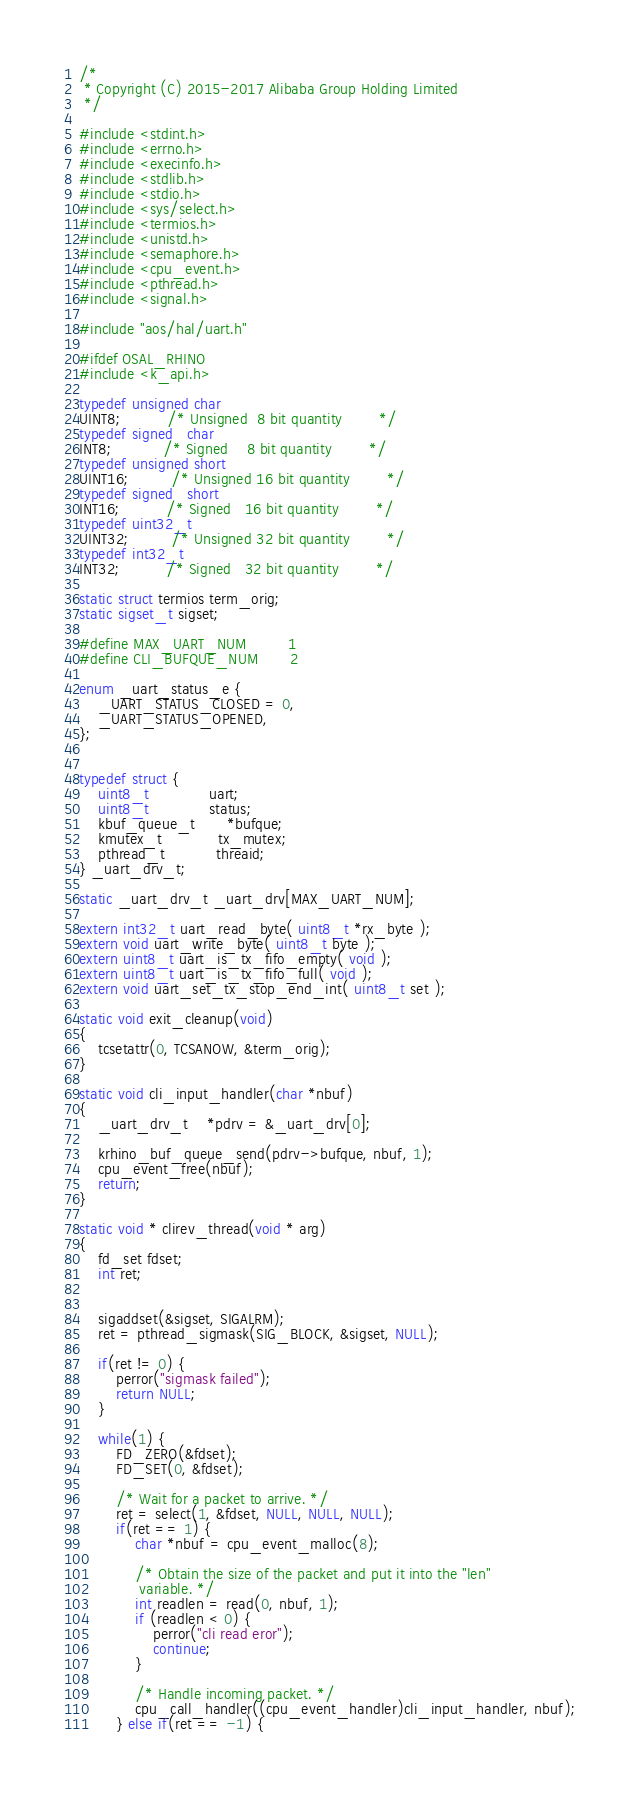<code> <loc_0><loc_0><loc_500><loc_500><_C_>/*
 * Copyright (C) 2015-2017 Alibaba Group Holding Limited
 */

#include <stdint.h>
#include <errno.h>
#include <execinfo.h>
#include <stdlib.h>
#include <stdio.h>
#include <sys/select.h>
#include <termios.h>
#include <unistd.h>
#include <semaphore.h>
#include <cpu_event.h>
#include <pthread.h>
#include <signal.h>

#include "aos/hal/uart.h"

#ifdef OSAL_RHINO
#include <k_api.h>

typedef unsigned char
UINT8;          /* Unsigned  8 bit quantity        */
typedef signed   char
INT8;           /* Signed    8 bit quantity        */
typedef unsigned short
UINT16;         /* Unsigned 16 bit quantity        */
typedef signed   short
INT16;          /* Signed   16 bit quantity        */
typedef uint32_t
UINT32;         /* Unsigned 32 bit quantity        */
typedef int32_t
INT32;          /* Signed   32 bit quantity        */

static struct termios term_orig;
static sigset_t sigset;

#define MAX_UART_NUM         1
#define CLI_BUFQUE_NUM       2

enum _uart_status_e {
    _UART_STATUS_CLOSED = 0,
    _UART_STATUS_OPENED,
};


typedef struct {
    uint8_t             uart;
    uint8_t             status;
    kbuf_queue_t       *bufque;
    kmutex_t            tx_mutex;
    pthread_t           threaid;
} _uart_drv_t;

static _uart_drv_t _uart_drv[MAX_UART_NUM];

extern int32_t uart_read_byte( uint8_t *rx_byte );
extern void uart_write_byte( uint8_t byte );
extern uint8_t uart_is_tx_fifo_empty( void );
extern uint8_t uart_is_tx_fifo_full( void );
extern void uart_set_tx_stop_end_int( uint8_t set );

static void exit_cleanup(void)
{
    tcsetattr(0, TCSANOW, &term_orig);
}

static void cli_input_handler(char *nbuf)
{
    _uart_drv_t    *pdrv = &_uart_drv[0];

    krhino_buf_queue_send(pdrv->bufque, nbuf, 1);
    cpu_event_free(nbuf);
    return;
}

static void * clirev_thread(void * arg)
{
    fd_set fdset;
    int ret;


    sigaddset(&sigset, SIGALRM);
    ret = pthread_sigmask(SIG_BLOCK, &sigset, NULL);

    if(ret != 0) {
        perror("sigmask failed");
        return NULL;
    }

    while(1) {
        FD_ZERO(&fdset);
        FD_SET(0, &fdset);

        /* Wait for a packet to arrive. */
        ret = select(1, &fdset, NULL, NULL, NULL);
        if(ret == 1) {
            char *nbuf = cpu_event_malloc(8);

            /* Obtain the size of the packet and put it into the "len"
             variable. */
            int readlen = read(0, nbuf, 1);
            if (readlen < 0) {
                perror("cli read eror");
                continue;
            }

            /* Handle incoming packet. */
            cpu_call_handler((cpu_event_handler)cli_input_handler, nbuf);
        } else if(ret == -1) {</code> 